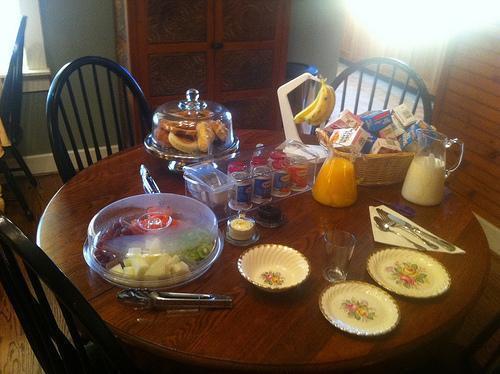How many plates are there?
Give a very brief answer. 2. 